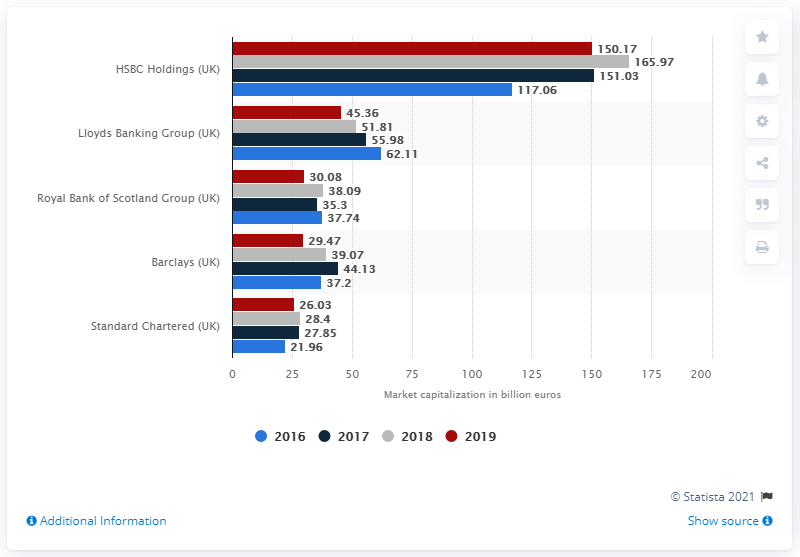Identify some key points in this picture. HSBC's market capital in May 2018 was 151.03. 